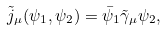Convert formula to latex. <formula><loc_0><loc_0><loc_500><loc_500>\tilde { j } _ { \mu } ( \psi _ { 1 } , \psi _ { 2 } ) = \bar { \psi } _ { 1 } \tilde { \gamma } _ { \mu } \psi _ { 2 } ,</formula> 